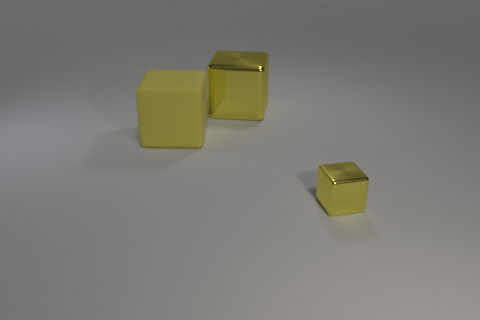Can you tell me about the lighting in the photo? The lighting in the photo is soft and diffused, creating gentle shadows to the right of the cubes. This style of lighting avoids harsh contrasts and suggests that the light source is not directly overhead but may be situated off to the side, contributing to the tranquil and even tone of the photo. 